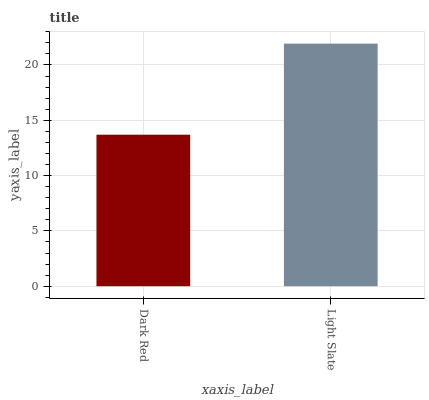Is Dark Red the minimum?
Answer yes or no. Yes. Is Light Slate the maximum?
Answer yes or no. Yes. Is Light Slate the minimum?
Answer yes or no. No. Is Light Slate greater than Dark Red?
Answer yes or no. Yes. Is Dark Red less than Light Slate?
Answer yes or no. Yes. Is Dark Red greater than Light Slate?
Answer yes or no. No. Is Light Slate less than Dark Red?
Answer yes or no. No. Is Light Slate the high median?
Answer yes or no. Yes. Is Dark Red the low median?
Answer yes or no. Yes. Is Dark Red the high median?
Answer yes or no. No. Is Light Slate the low median?
Answer yes or no. No. 